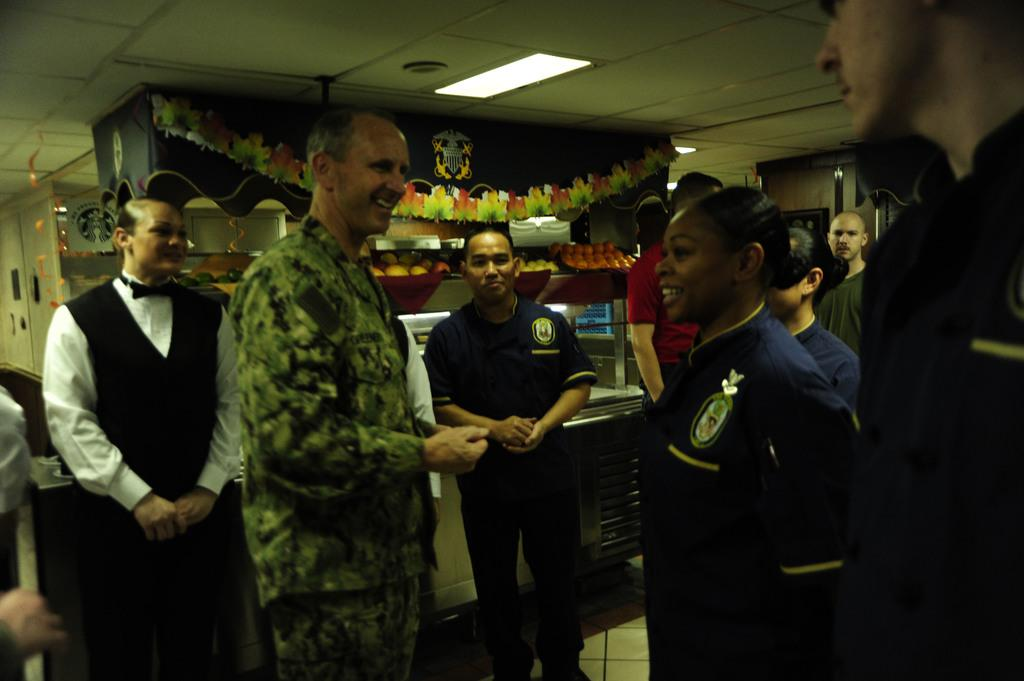What is the main subject of the image? The main subject of the image is a group of people. How can you describe the appearance of the people in the image? The people are wearing different color dresses. What can be seen in the background of the image? There is a stall with food items in the background. What is visible at the top of the image? Lights are visible at the top of the image. What type of weather can be seen in the image? The provided facts do not mention any weather conditions, so it cannot be determined from the image. 